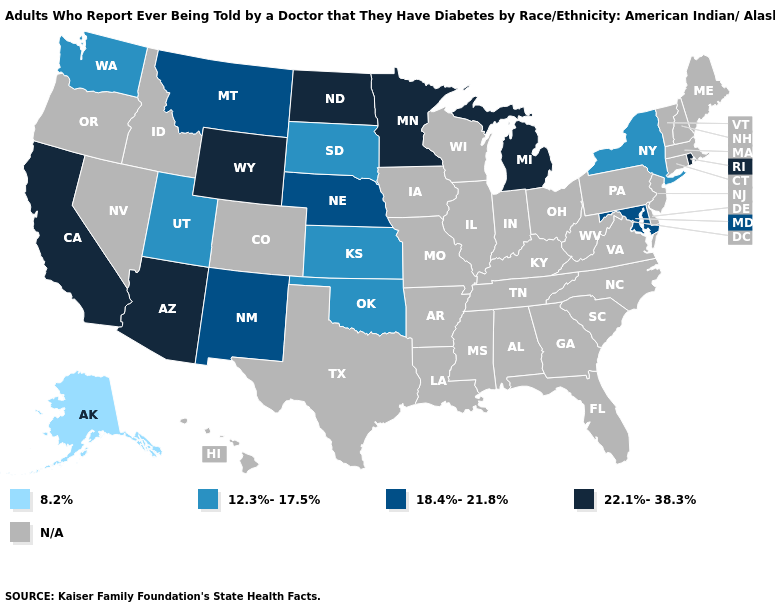Name the states that have a value in the range N/A?
Keep it brief. Alabama, Arkansas, Colorado, Connecticut, Delaware, Florida, Georgia, Hawaii, Idaho, Illinois, Indiana, Iowa, Kentucky, Louisiana, Maine, Massachusetts, Mississippi, Missouri, Nevada, New Hampshire, New Jersey, North Carolina, Ohio, Oregon, Pennsylvania, South Carolina, Tennessee, Texas, Vermont, Virginia, West Virginia, Wisconsin. Among the states that border Vermont , which have the highest value?
Short answer required. New York. Which states have the lowest value in the USA?
Quick response, please. Alaska. Is the legend a continuous bar?
Keep it brief. No. What is the value of Washington?
Answer briefly. 12.3%-17.5%. Is the legend a continuous bar?
Concise answer only. No. Does South Dakota have the highest value in the USA?
Concise answer only. No. Which states hav the highest value in the South?
Keep it brief. Maryland. Which states have the highest value in the USA?
Write a very short answer. Arizona, California, Michigan, Minnesota, North Dakota, Rhode Island, Wyoming. What is the highest value in the USA?
Concise answer only. 22.1%-38.3%. What is the value of Nebraska?
Short answer required. 18.4%-21.8%. Does Montana have the highest value in the USA?
Quick response, please. No. Does the first symbol in the legend represent the smallest category?
Quick response, please. Yes. What is the lowest value in the USA?
Write a very short answer. 8.2%. Name the states that have a value in the range 8.2%?
Give a very brief answer. Alaska. 